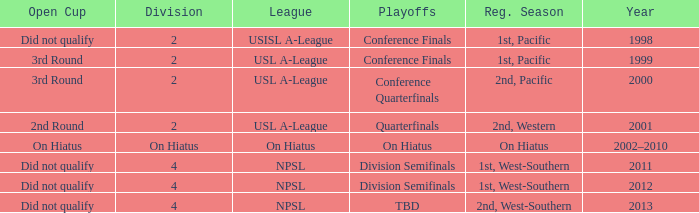Which open cup was in 2012? Did not qualify. 